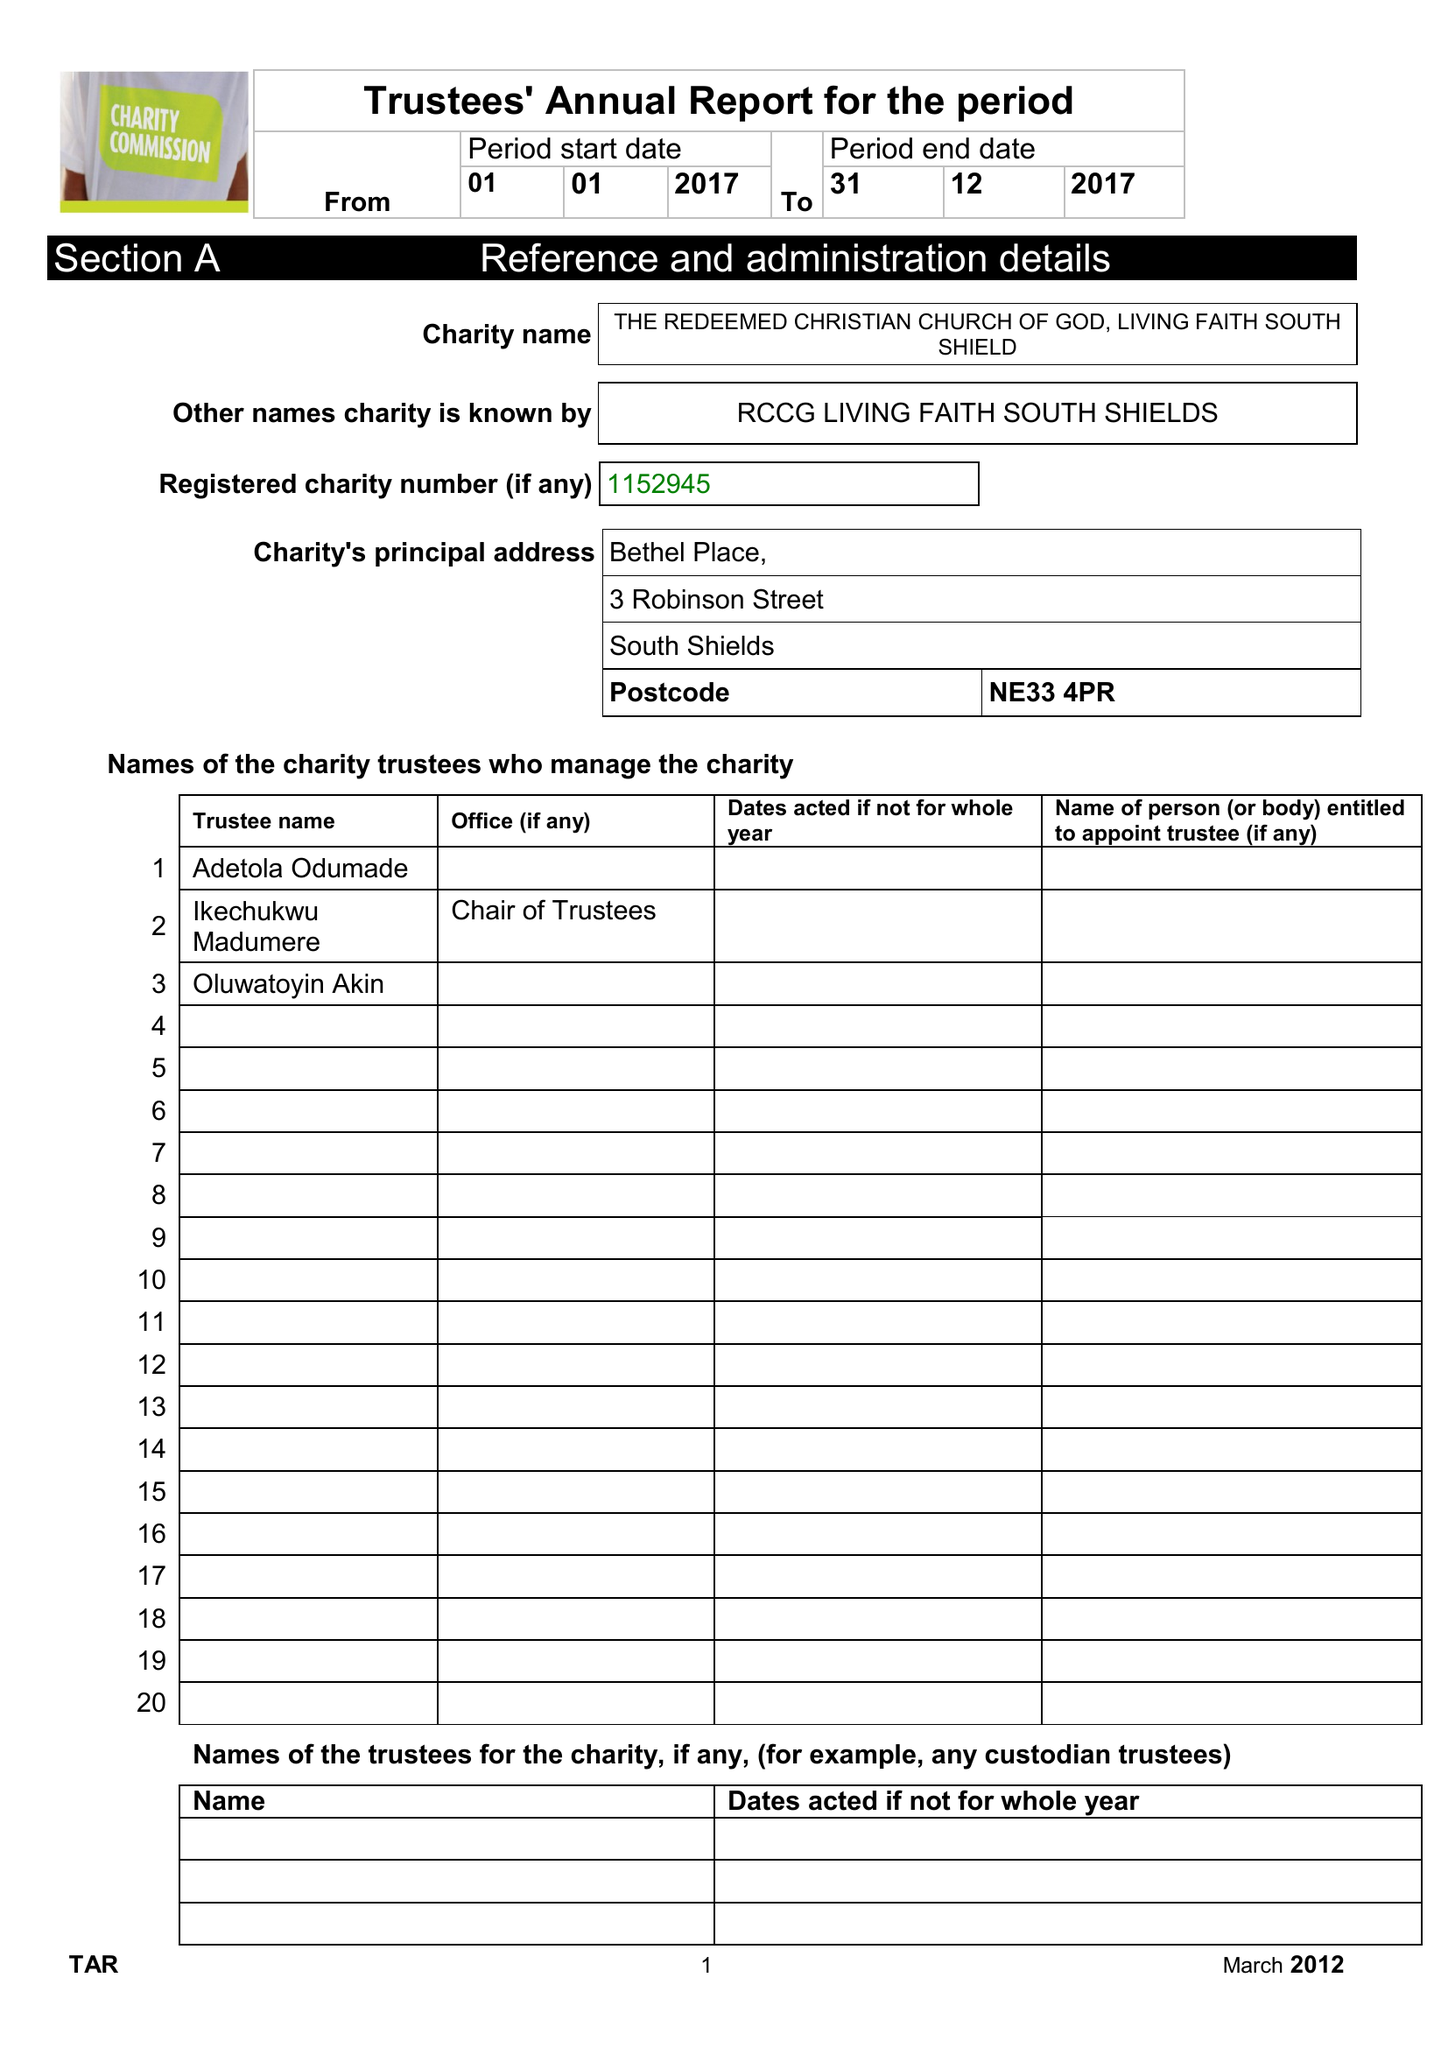What is the value for the charity_number?
Answer the question using a single word or phrase. 1152945 